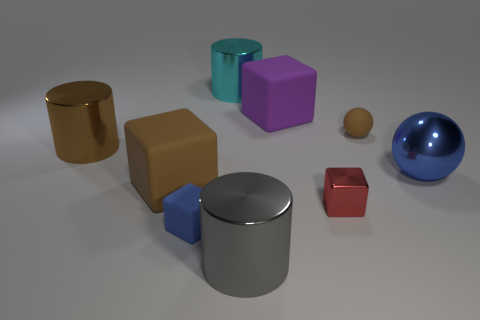What number of small metallic objects are right of the blue sphere? To the right of the blue sphere, there are no small metallic objects present. 